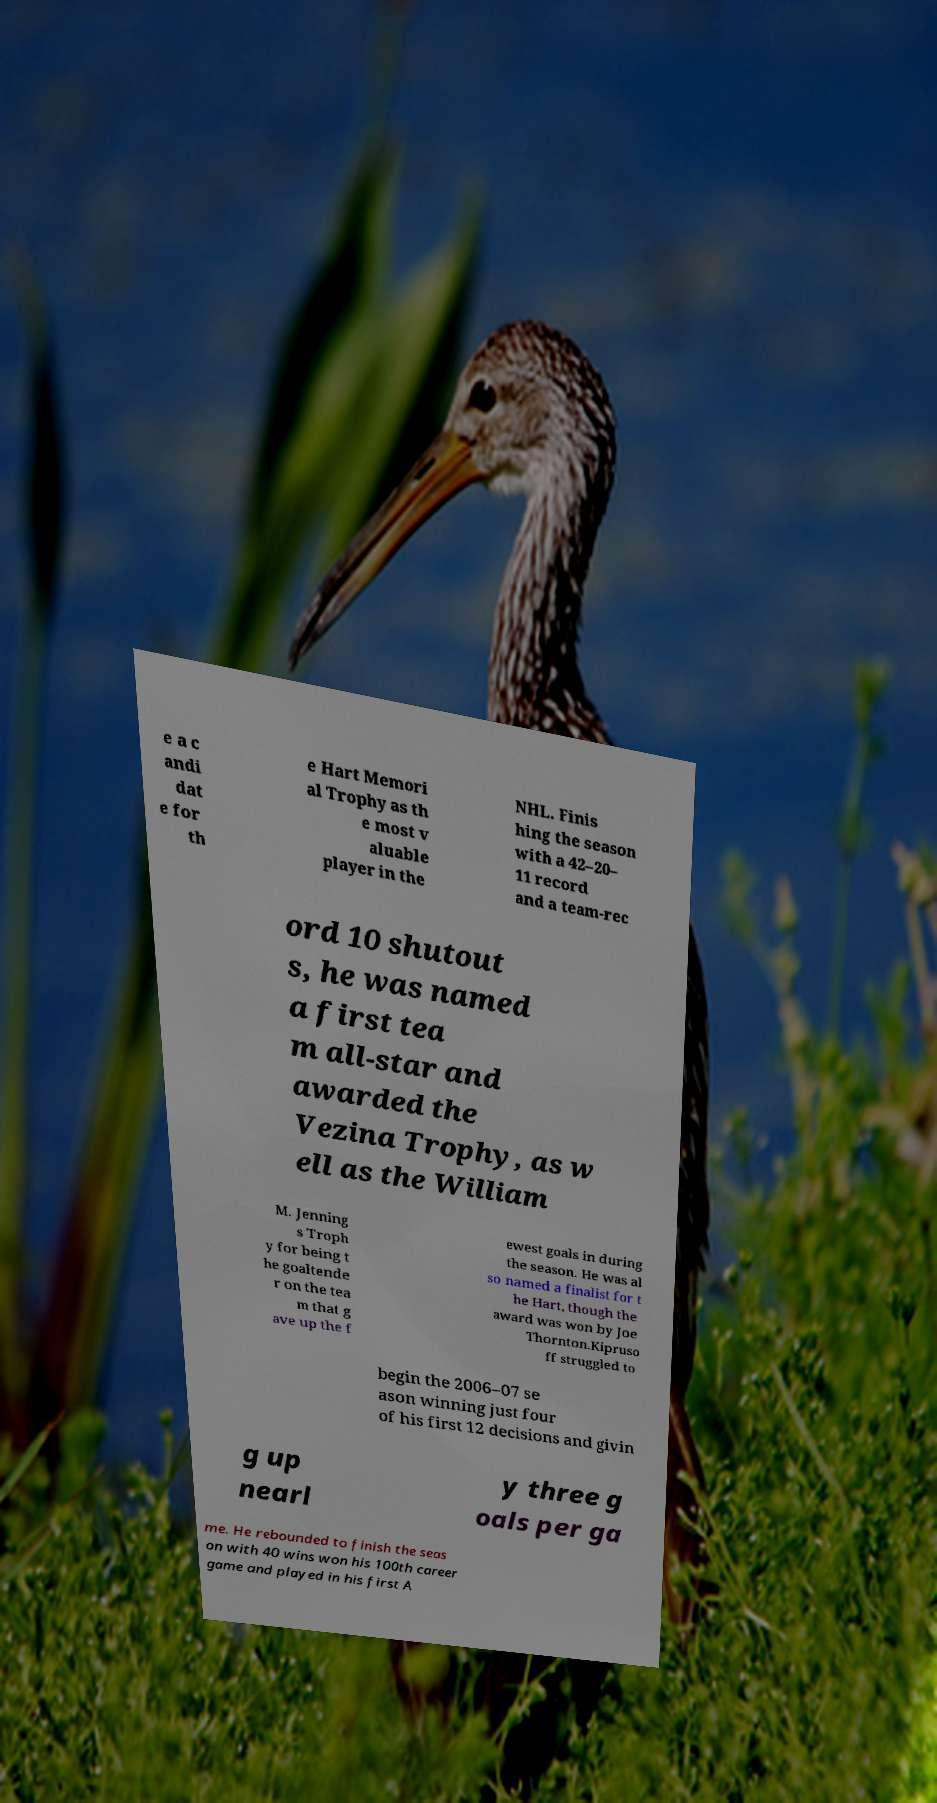Can you read and provide the text displayed in the image?This photo seems to have some interesting text. Can you extract and type it out for me? e a c andi dat e for th e Hart Memori al Trophy as th e most v aluable player in the NHL. Finis hing the season with a 42–20– 11 record and a team-rec ord 10 shutout s, he was named a first tea m all-star and awarded the Vezina Trophy, as w ell as the William M. Jenning s Troph y for being t he goaltende r on the tea m that g ave up the f ewest goals in during the season. He was al so named a finalist for t he Hart, though the award was won by Joe Thornton.Kipruso ff struggled to begin the 2006–07 se ason winning just four of his first 12 decisions and givin g up nearl y three g oals per ga me. He rebounded to finish the seas on with 40 wins won his 100th career game and played in his first A 